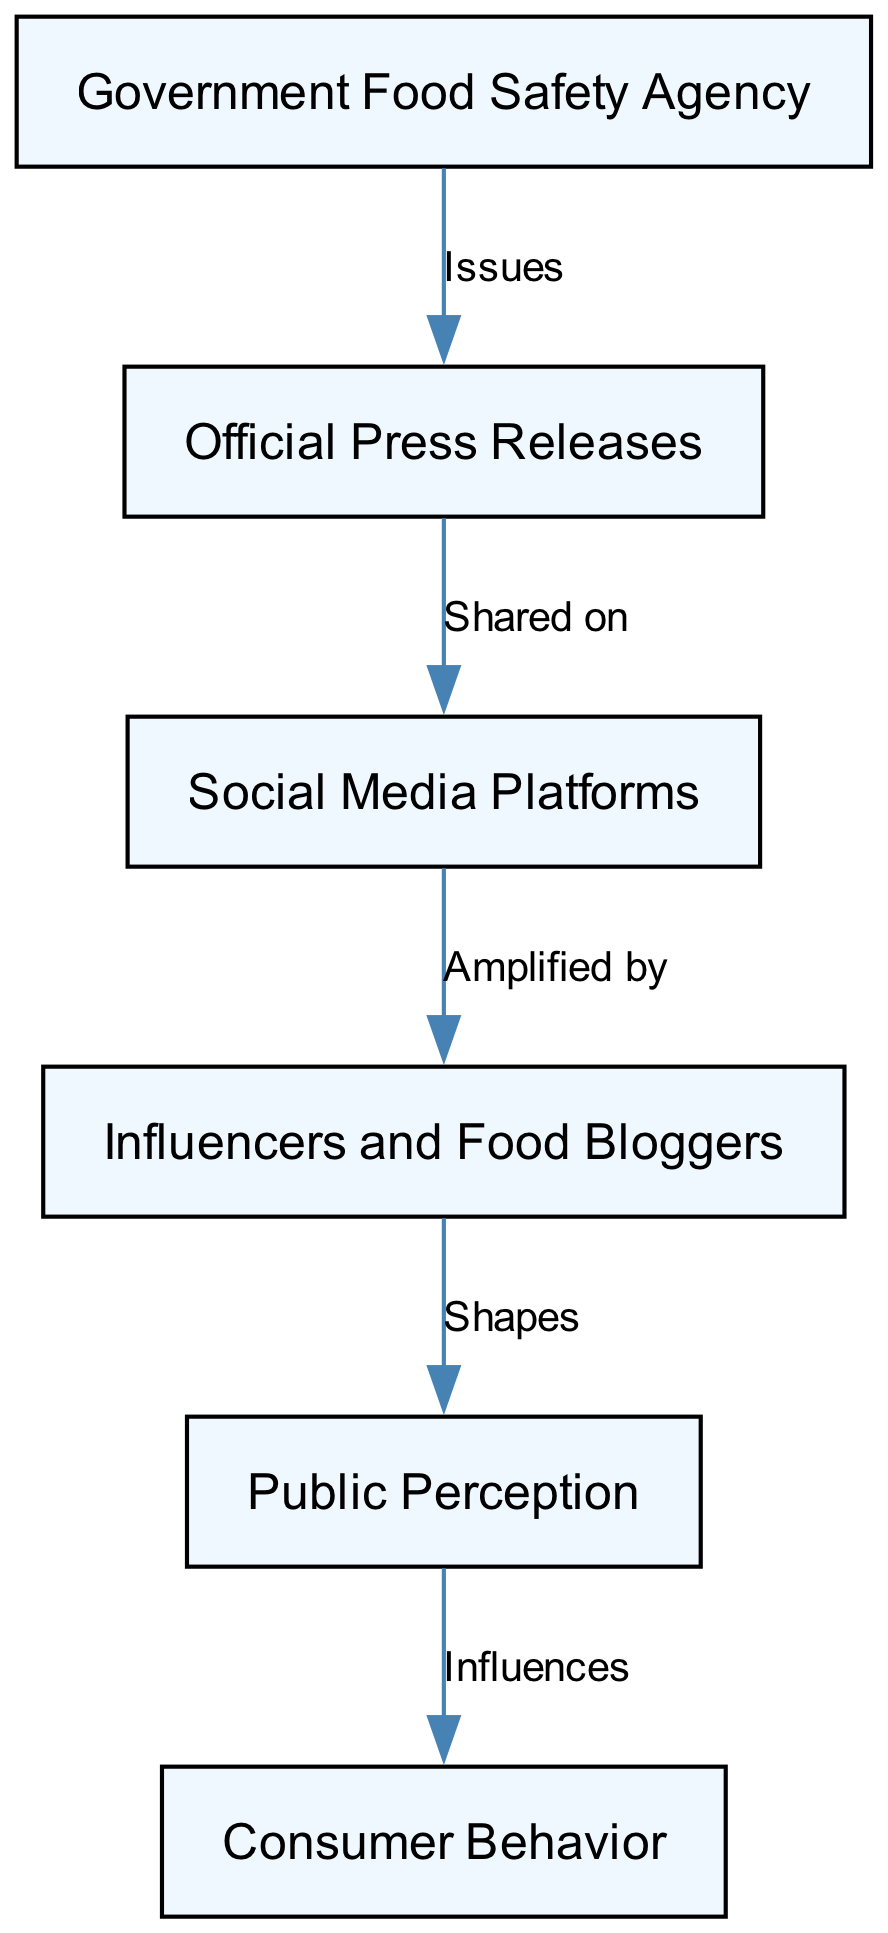What is the first node in the food chain? The first node is the "Government Food Safety Agency," which establishes the basis for the diagram.
Answer: Government Food Safety Agency How many edges are present in the diagram? There are a total of 5 edges connecting the nodes, representing the relationships between them.
Answer: 5 What does the "Official Press Releases" node do to the "Social Media Platforms"? The "Official Press Releases" are "Shared on" the "Social Media Platforms," indicating a direct action.
Answer: Shared on Which node influences "Consumer Behavior"? The node "Public Perception" influences "Consumer Behavior," indicating that how the public perceives food safety affects their purchasing decisions.
Answer: Public Perception What role do "Influencers and Food Bloggers" play in shaping public perception? They "Shapes" the "Public Perception" through their content, affecting how the public views food safety and quality.
Answer: Shapes Which node connects the "Government Food Safety Agency" to the "Social Media Platforms"? The connection is through the "Official Press Releases," which serve to communicate official information that is then transmitted through social media.
Answer: Official Press Releases How many nodes are involved in this food chain? There are 6 nodes in total, which include all parties involved in the information flow regarding food safety.
Answer: 6 Which node acts as an intermediary between the "Social Media Platforms" and the "Public Perception"? The "Influencers and Food Bloggers" act as intermediaries, amplifying the messages from social media to the public.
Answer: Influencers and Food Bloggers What does "Social Media Platforms" do with the information from the "Official Press Releases"? They help to amplify the messages, making the information more widely accessible to the public.
Answer: Amplified by 